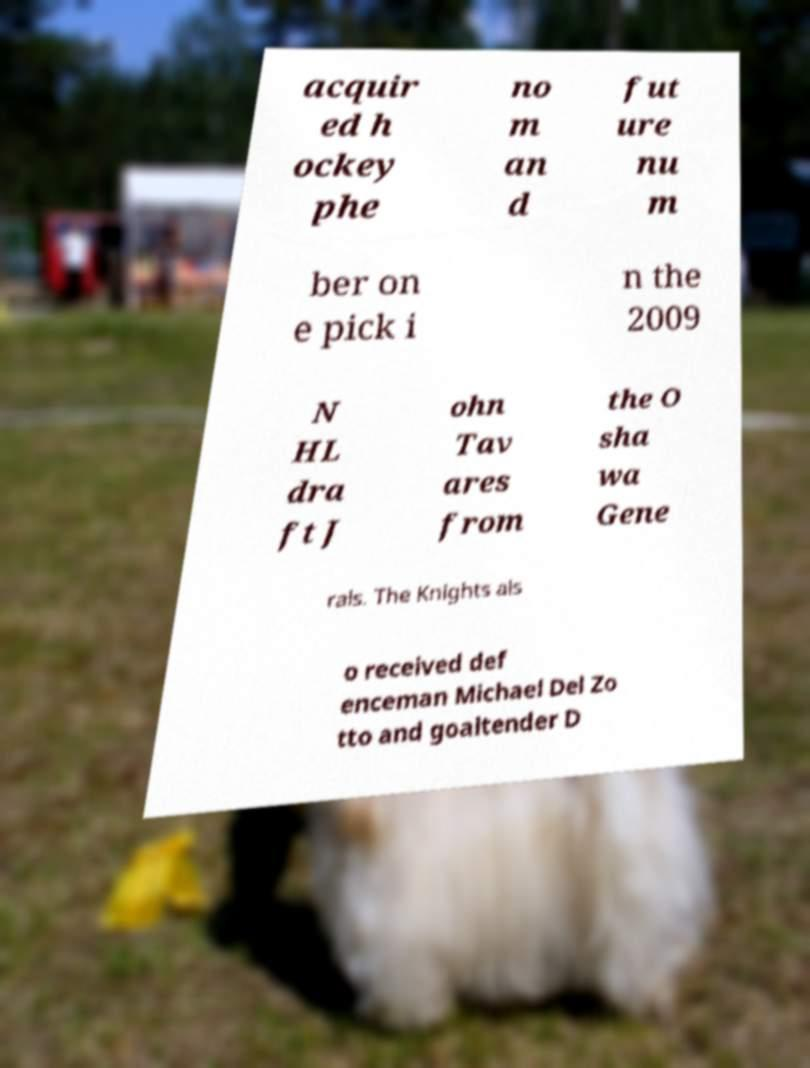There's text embedded in this image that I need extracted. Can you transcribe it verbatim? acquir ed h ockey phe no m an d fut ure nu m ber on e pick i n the 2009 N HL dra ft J ohn Tav ares from the O sha wa Gene rals. The Knights als o received def enceman Michael Del Zo tto and goaltender D 